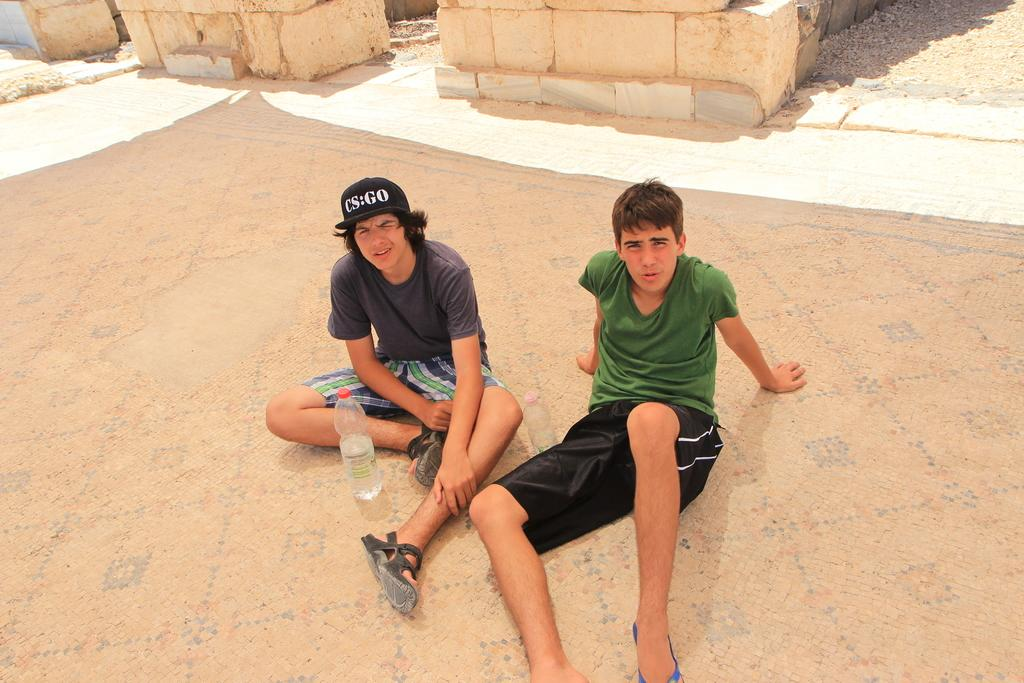How many people are in the image? There are two men in the image. What are the men doing in the image? The men are sitting on a surface. What objects can be seen near the men? There are bottles visible in the image. What can be seen in the background of the image? There are walls in the background of the image. What type of tank is visible in the image? There is no tank present in the image. Is the steam coming out of the bottles in the image? There is no steam visible in the image, and the bottles are not described as having steam coming out of them. 